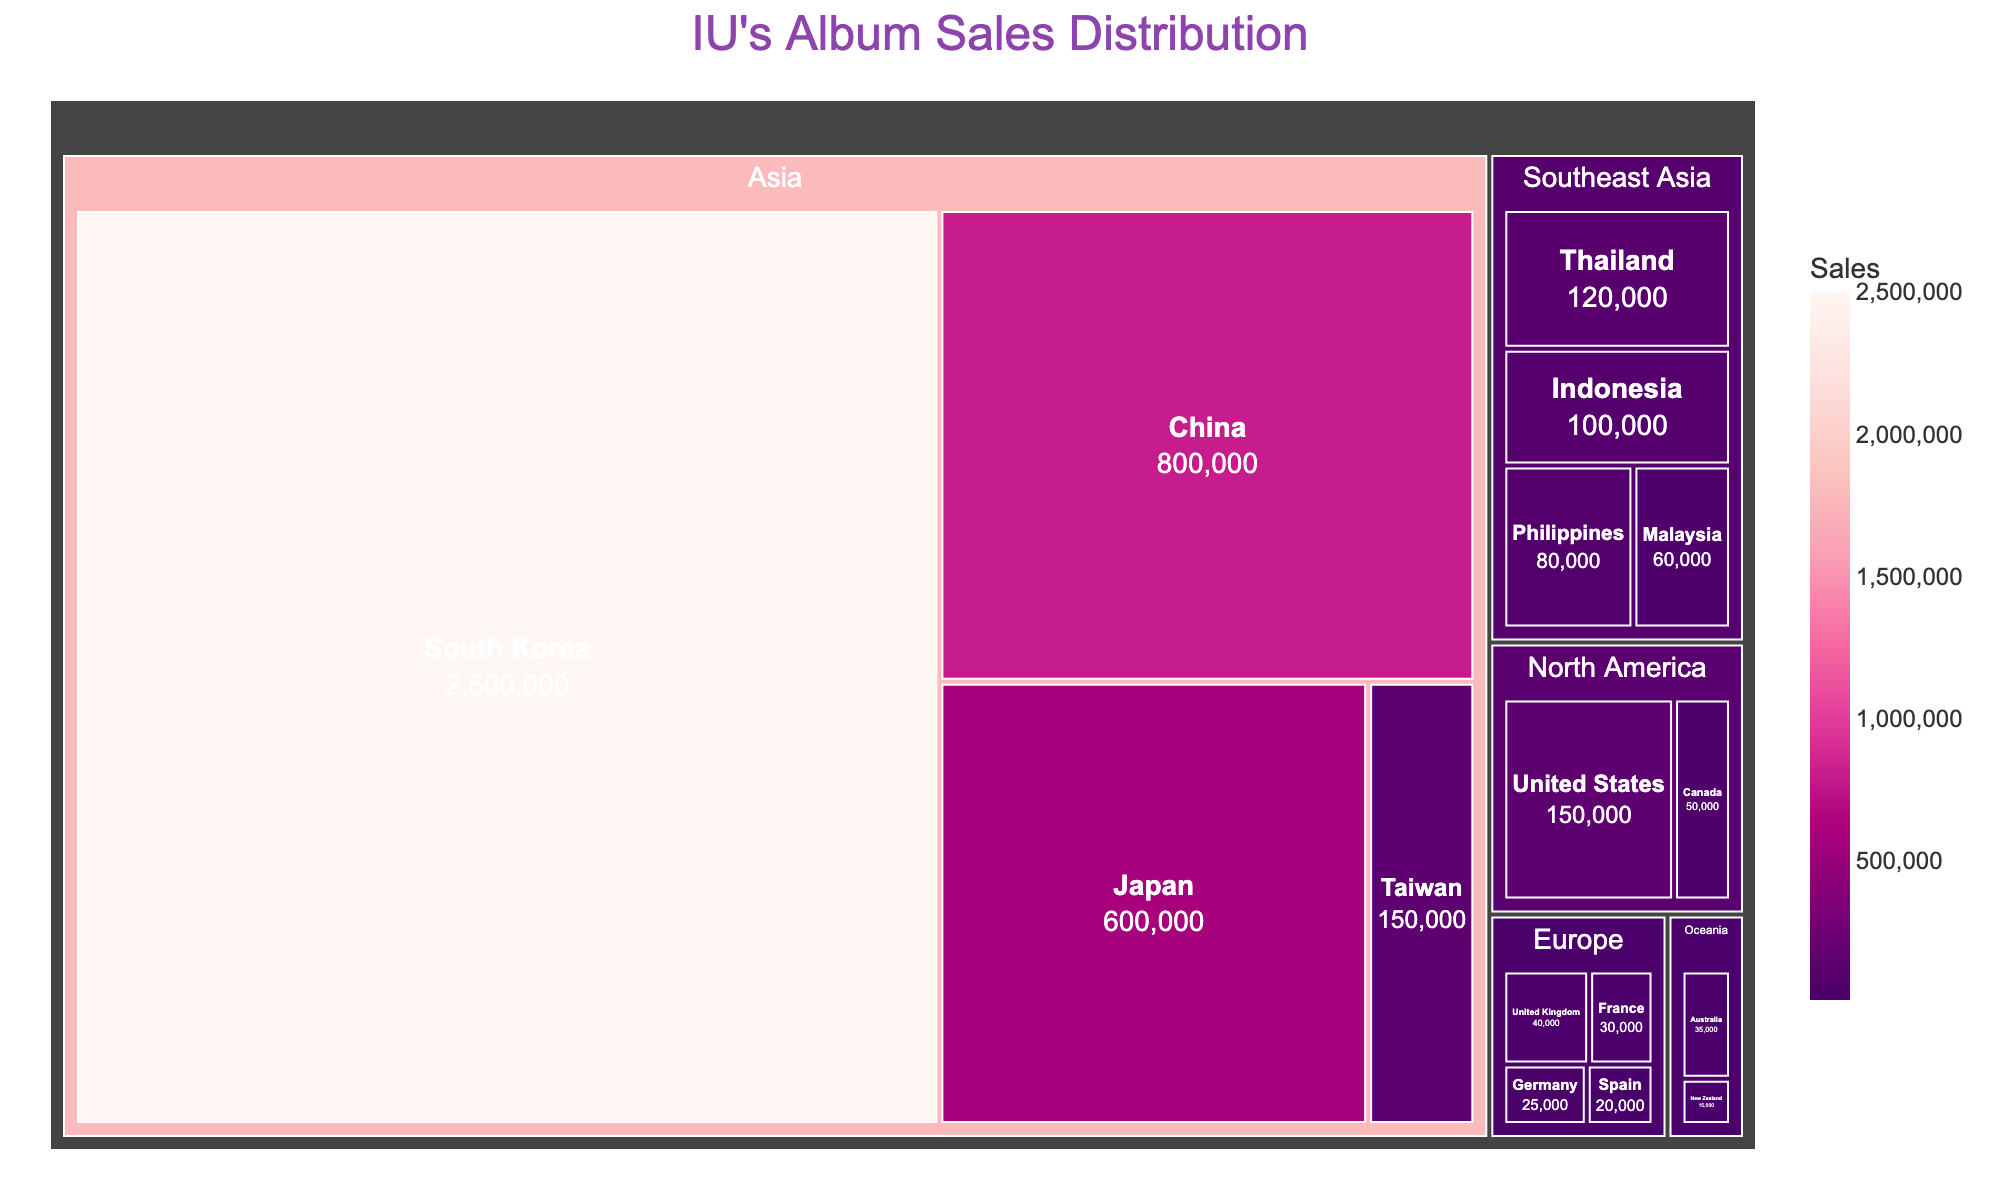How many regions are displayed in the treemap? The treemap groups the countries into different regions. By visually inspecting the tree structure, we can count the number of distinct regions.
Answer: 5 Which country in Southeast Asia has the highest sales? The Southeast Asia region contains several countries. By examining the blocks under "Southeast Asia," we can identify the one with the largest sales figure.
Answer: Thailand What is the total sales figure for North America? To find the total sales for North America, sum up the sales figures of the United States and Canada.
Answer: 200,000 Which country has the smallest sales and how much are they? By looking for the smallest block in the entire treemap and reading its sales value, we can identify the country with the smallest sales.
Answer: New Zealand, 15,000 Compare the album sales between South Korea and the total sales of Europe. Which is higher? First, note the sales figure for South Korea (2,500,000). Then, sum the sales for all European countries (United Kingdom, France, Germany, and Spain) and compare the two figures.
Answer: South Korea What is the percentage contribution of China to the total sales in Asia? Calculate the total sales in Asia by summing all relevant countries (South Korea, China, Japan, and Taiwan). Then, use the formula (China's sales / total sales in Asia) * 100.
Answer: 17.4% What's the difference in album sales between Taiwan and the Philippines? Note the sales figures for Taiwan (150,000) and the Philippines (80,000), and subtract the sales of the Philippines from Taiwan.
Answer: 70,000 Which region has the most diversified sales distribution, and why? By viewing the relative sizes of the blocks within each region, the region with blocks of varying sizes represents a more diversified distribution.
Answer: Asia, because it contains countries with varying sales figures such as South Korea with very high sales and Taiwan with lower sales 